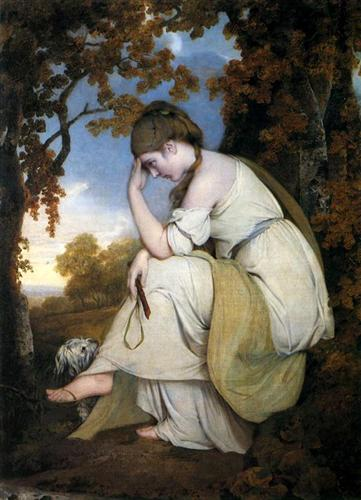Picture this scene as part of a beloved fairytale. Provide a brief summary of the tale. In a distant kingdom, a young maiden named Liora was known for her gentle heart and deep connection to the natural world. Orphaned young, she found solace in the woods, where she would spend her days in quiet contemplation, often in the company of her faithful dog. One fateful evening, as the sun set and the forest bathed in a golden glow, Liora discovered an ancient, hidden path. This path led her to a magical realm where the trees spoke in whispers, and mythical creatures dwelled. The forest spirits, sensing her pure heart, bestowed upon her the power to heal the land and bring peace to her troubled kingdom. Through wisdom, courage, and compassion, Liora united her people and the enchanted beings, restoring harmony to both realms. 